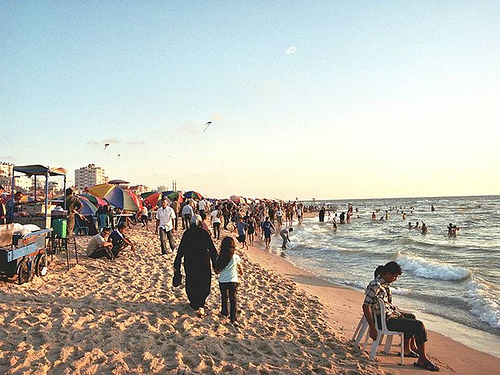Are there both a table and a chair in this picture? There is only a chair visible in the image, located on the sandy beach; no table is present. 